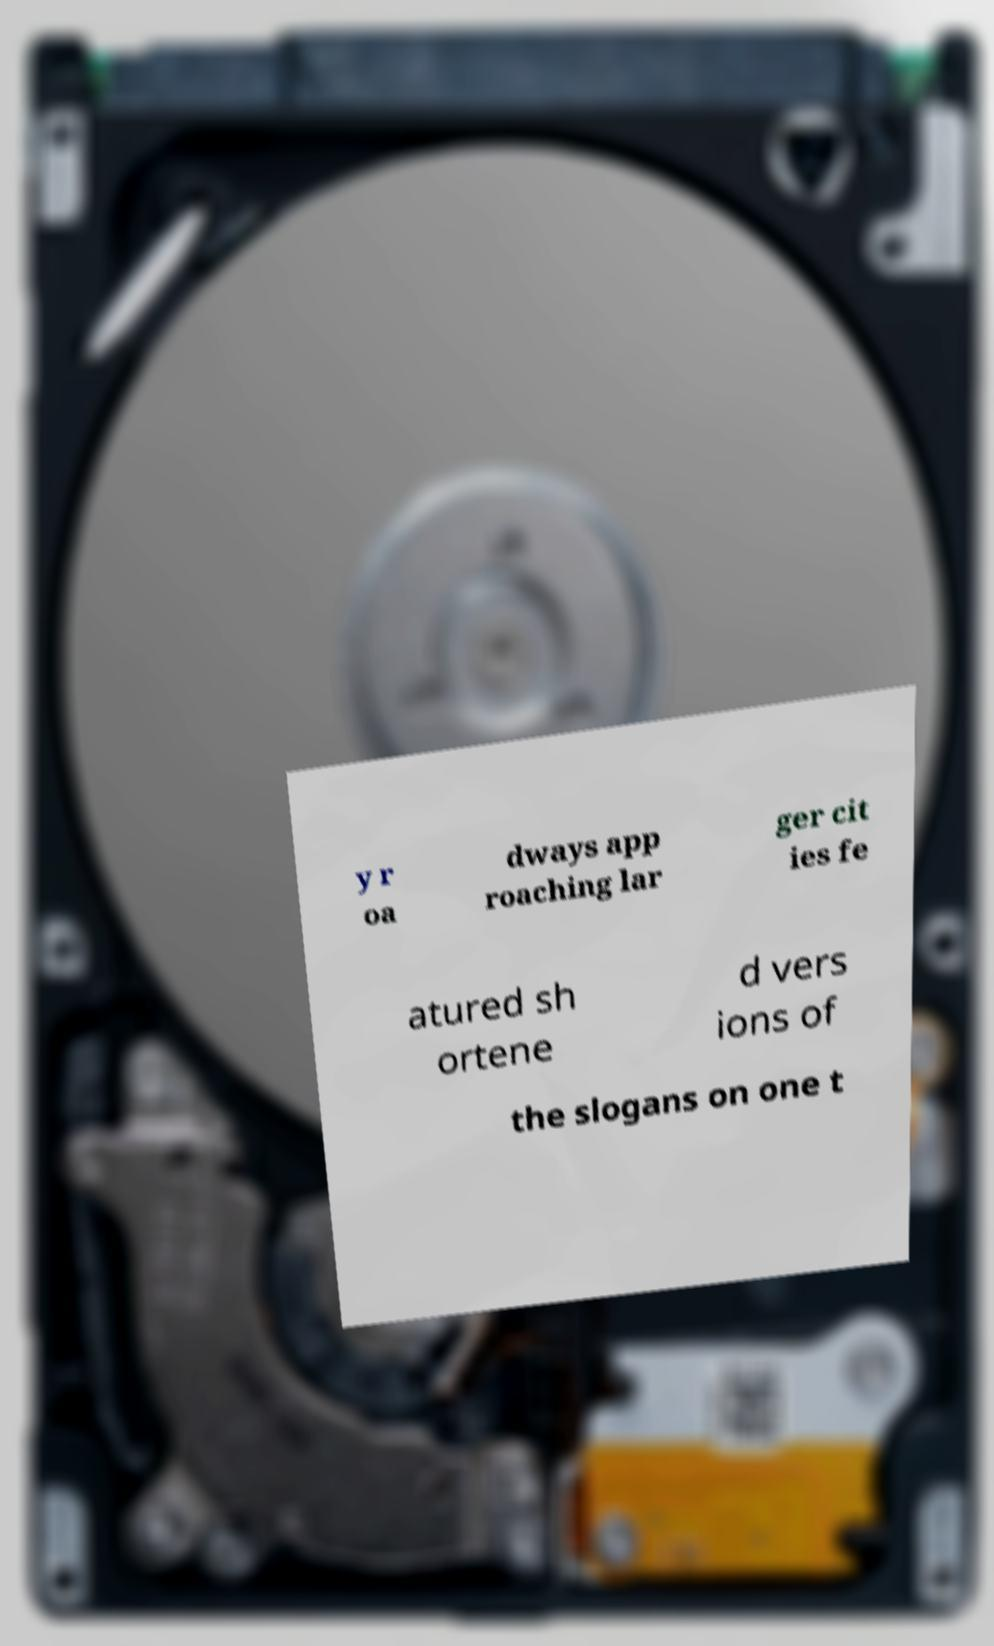Could you extract and type out the text from this image? y r oa dways app roaching lar ger cit ies fe atured sh ortene d vers ions of the slogans on one t 